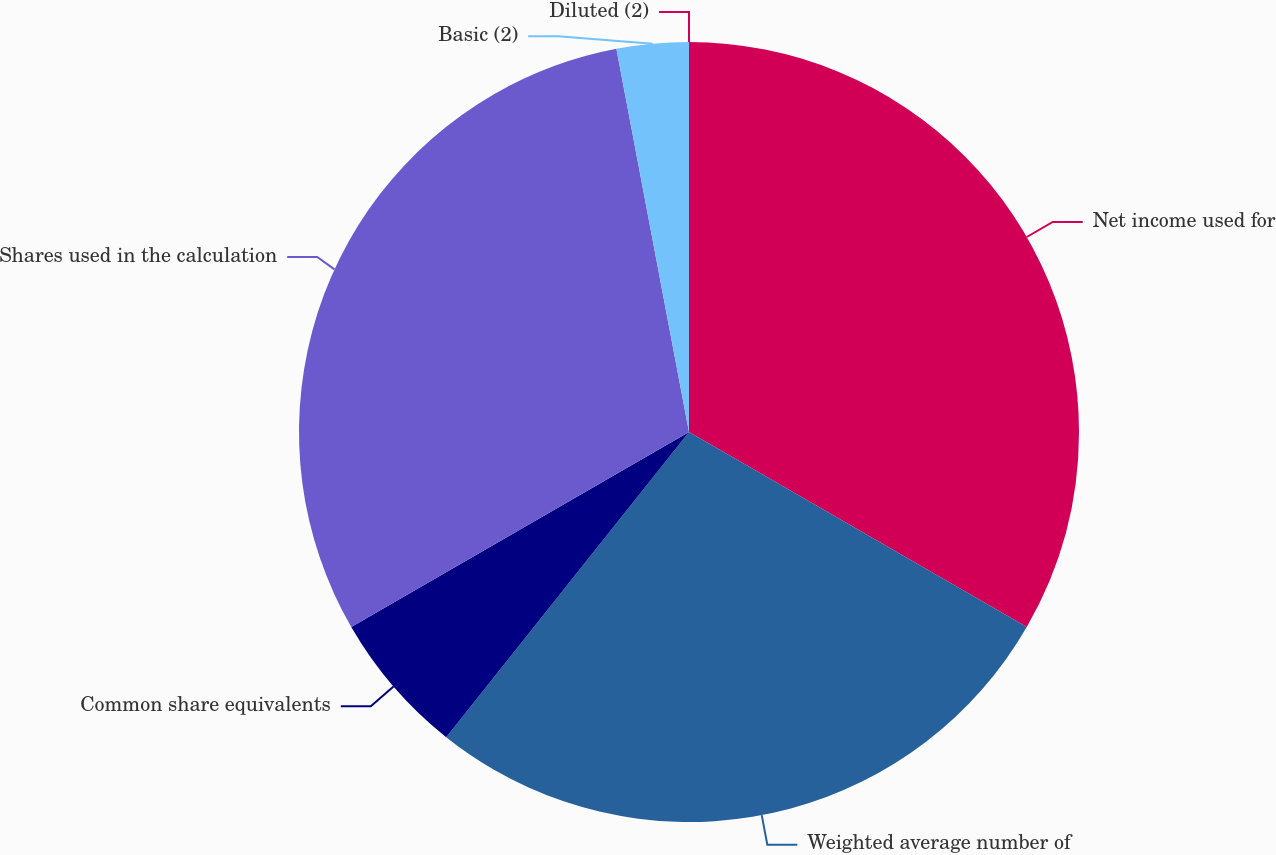<chart> <loc_0><loc_0><loc_500><loc_500><pie_chart><fcel>Net income used for<fcel>Weighted average number of<fcel>Common share equivalents<fcel>Shares used in the calculation<fcel>Basic (2)<fcel>Diluted (2)<nl><fcel>33.33%<fcel>27.36%<fcel>5.97%<fcel>30.35%<fcel>2.98%<fcel>0.0%<nl></chart> 